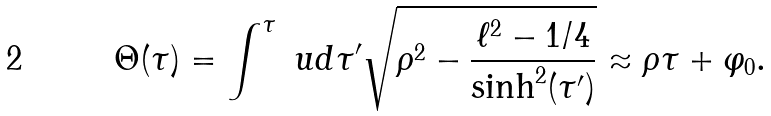Convert formula to latex. <formula><loc_0><loc_0><loc_500><loc_500>\Theta ( \tau ) = \int ^ { \tau } \ u d \tau ^ { \prime } \sqrt { \rho ^ { 2 } - \frac { \ell ^ { 2 } - 1 / 4 } { \sinh ^ { 2 } ( \tau ^ { \prime } ) } } \approx \rho \tau + \varphi _ { 0 } .</formula> 